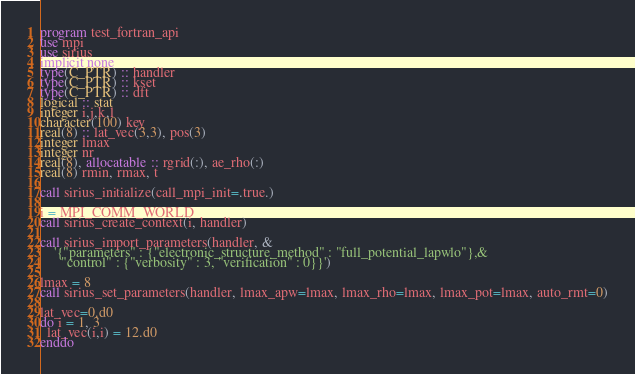<code> <loc_0><loc_0><loc_500><loc_500><_FORTRAN_>program test_fortran_api
use mpi
use sirius
implicit none
type(C_PTR) :: handler
type(C_PTR) :: kset
type(C_PTR) :: dft
logical :: stat
integer i,j,k,l
character(100) key
real(8) :: lat_vec(3,3), pos(3)
integer lmax
integer nr
real(8), allocatable :: rgrid(:), ae_rho(:)
real(8) rmin, rmax, t

call sirius_initialize(call_mpi_init=.true.)

i = MPI_COMM_WORLD
call sirius_create_context(i, handler)

call sirius_import_parameters(handler, &
    '{"parameters" : {"electronic_structure_method" : "full_potential_lapwlo"},&
      "control" : {"verbosity" : 3, "verification" : 0}}')

lmax = 8
call sirius_set_parameters(handler, lmax_apw=lmax, lmax_rho=lmax, lmax_pot=lmax, auto_rmt=0)

lat_vec=0.d0
do i = 1, 3
  lat_vec(i,i) = 12.d0
enddo
</code> 